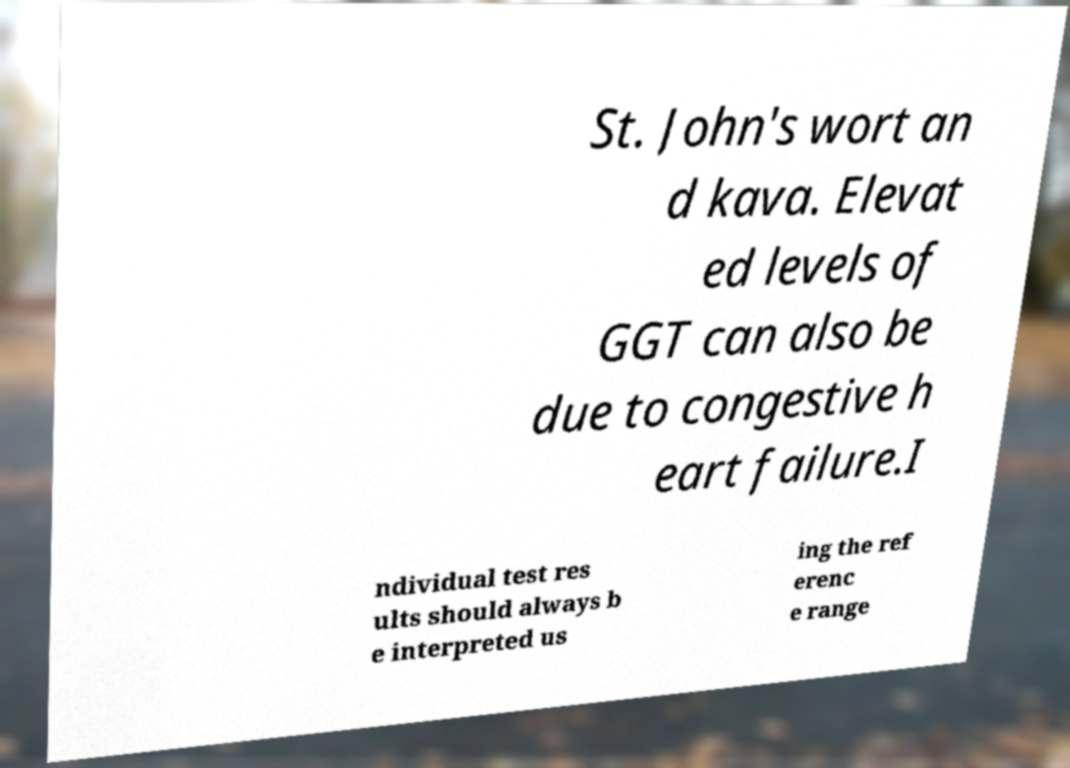I need the written content from this picture converted into text. Can you do that? St. John's wort an d kava. Elevat ed levels of GGT can also be due to congestive h eart failure.I ndividual test res ults should always b e interpreted us ing the ref erenc e range 